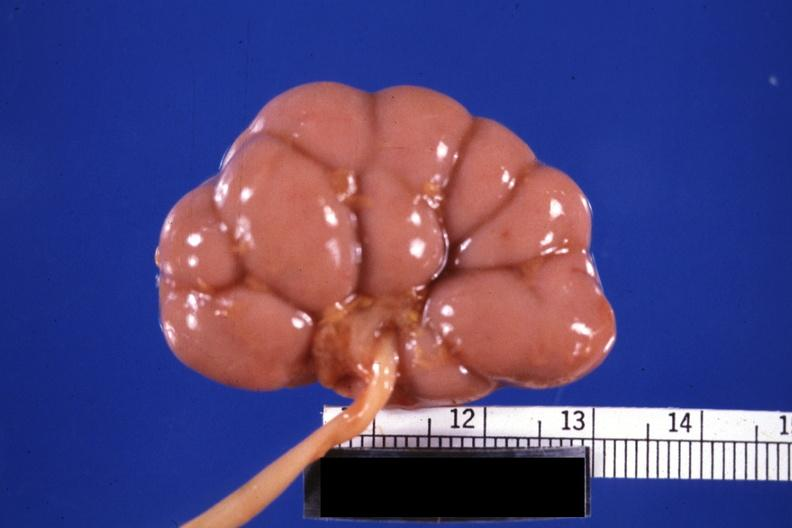does med excellent example of epidermal separation gross of this lesion show fixed tissue good example small kidney?
Answer the question using a single word or phrase. No 